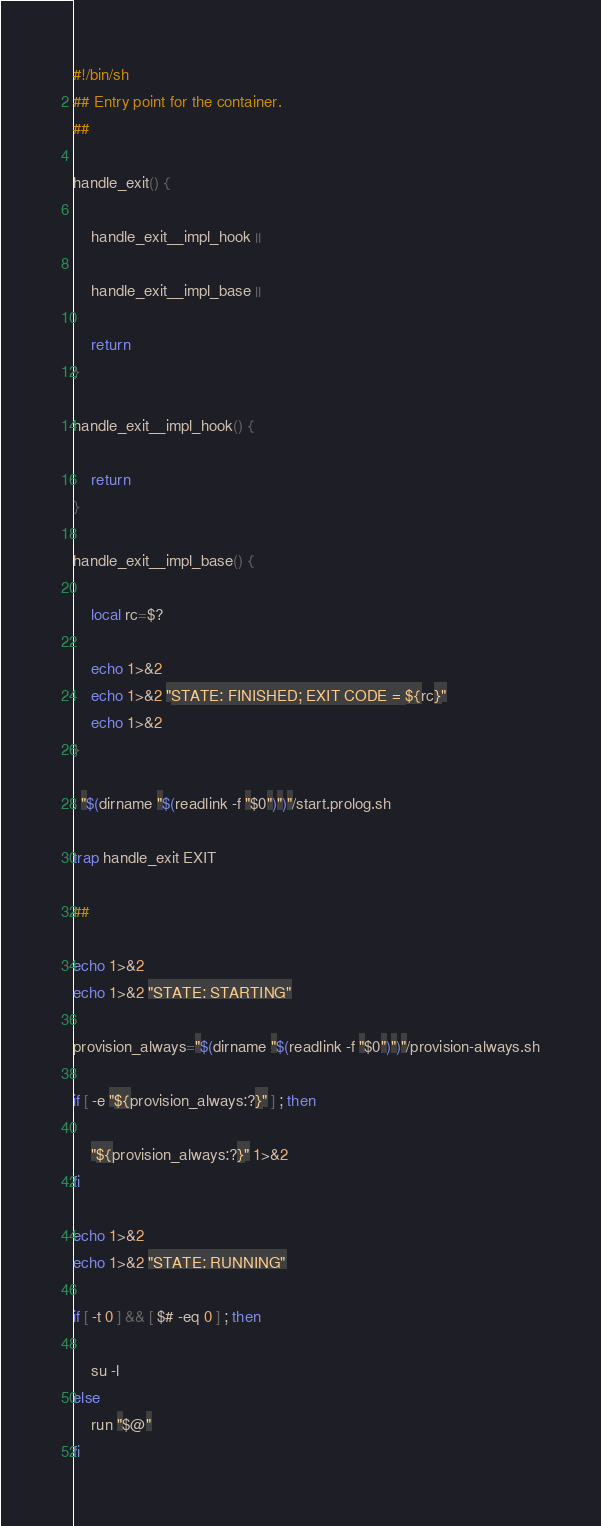Convert code to text. <code><loc_0><loc_0><loc_500><loc_500><_Bash_>#!/bin/sh
## Entry point for the container.
##

handle_exit() {

	handle_exit__impl_hook ||

	handle_exit__impl_base ||

	return
}

handle_exit__impl_hook() {

	return
}

handle_exit__impl_base() {

	local rc=$?

	echo 1>&2
	echo 1>&2 "STATE: FINISHED; EXIT CODE = ${rc}"
	echo 1>&2
}

. "$(dirname "$(readlink -f "$0")")"/start.prolog.sh

trap handle_exit EXIT

##

echo 1>&2
echo 1>&2 "STATE: STARTING"

provision_always="$(dirname "$(readlink -f "$0")")"/provision-always.sh

if [ -e "${provision_always:?}" ] ; then

	"${provision_always:?}" 1>&2
fi

echo 1>&2
echo 1>&2 "STATE: RUNNING"

if [ -t 0 ] && [ $# -eq 0 ] ; then

	su -l
else
	run "$@"
fi

</code> 